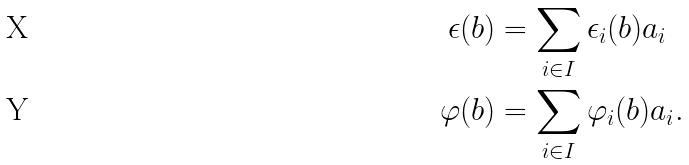<formula> <loc_0><loc_0><loc_500><loc_500>\epsilon ( b ) & = \sum _ { i \in I } \epsilon _ { i } ( b ) \L a _ { i } \\ \varphi ( b ) & = \sum _ { i \in I } \varphi _ { i } ( b ) \L a _ { i } .</formula> 